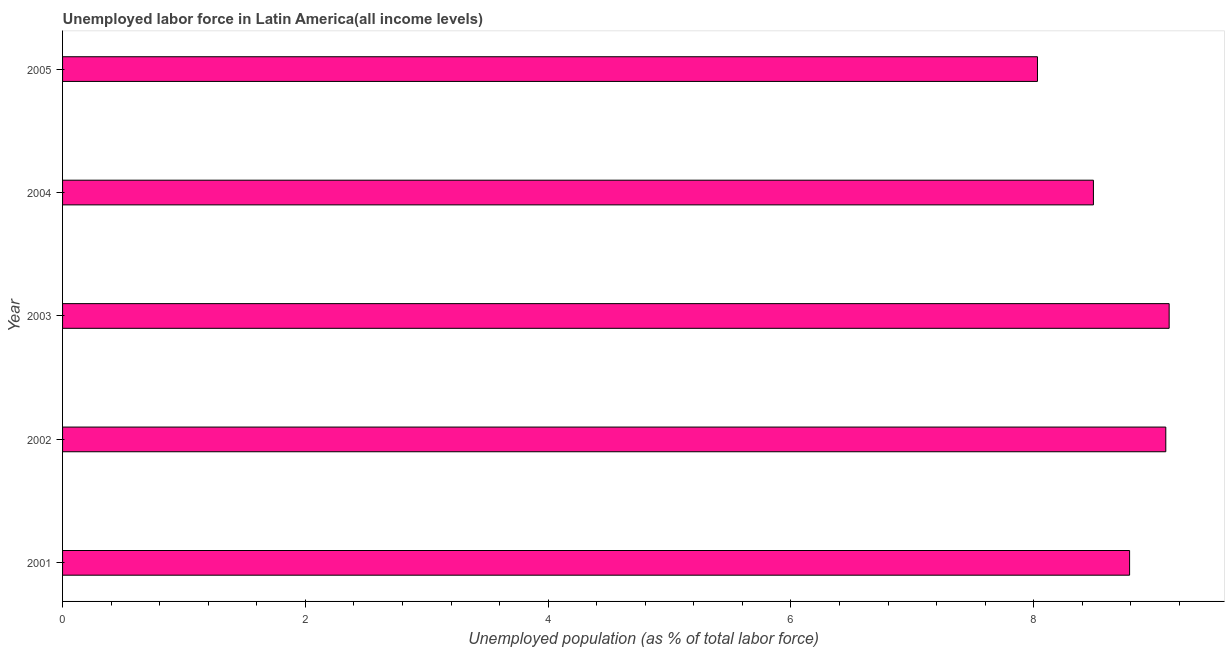Does the graph contain grids?
Your answer should be very brief. No. What is the title of the graph?
Keep it short and to the point. Unemployed labor force in Latin America(all income levels). What is the label or title of the X-axis?
Offer a terse response. Unemployed population (as % of total labor force). What is the total unemployed population in 2002?
Give a very brief answer. 9.09. Across all years, what is the maximum total unemployed population?
Make the answer very short. 9.12. Across all years, what is the minimum total unemployed population?
Your answer should be very brief. 8.03. In which year was the total unemployed population maximum?
Offer a terse response. 2003. What is the sum of the total unemployed population?
Ensure brevity in your answer.  43.52. What is the difference between the total unemployed population in 2002 and 2005?
Provide a succinct answer. 1.06. What is the average total unemployed population per year?
Give a very brief answer. 8.7. What is the median total unemployed population?
Ensure brevity in your answer.  8.79. What is the ratio of the total unemployed population in 2002 to that in 2005?
Offer a terse response. 1.13. Is the total unemployed population in 2001 less than that in 2005?
Your answer should be very brief. No. What is the difference between the highest and the second highest total unemployed population?
Offer a terse response. 0.03. What is the difference between the highest and the lowest total unemployed population?
Your response must be concise. 1.08. How many bars are there?
Your response must be concise. 5. What is the Unemployed population (as % of total labor force) of 2001?
Provide a succinct answer. 8.79. What is the Unemployed population (as % of total labor force) in 2002?
Keep it short and to the point. 9.09. What is the Unemployed population (as % of total labor force) in 2003?
Make the answer very short. 9.12. What is the Unemployed population (as % of total labor force) in 2004?
Keep it short and to the point. 8.49. What is the Unemployed population (as % of total labor force) in 2005?
Keep it short and to the point. 8.03. What is the difference between the Unemployed population (as % of total labor force) in 2001 and 2002?
Ensure brevity in your answer.  -0.3. What is the difference between the Unemployed population (as % of total labor force) in 2001 and 2003?
Give a very brief answer. -0.33. What is the difference between the Unemployed population (as % of total labor force) in 2001 and 2004?
Make the answer very short. 0.3. What is the difference between the Unemployed population (as % of total labor force) in 2001 and 2005?
Your answer should be very brief. 0.76. What is the difference between the Unemployed population (as % of total labor force) in 2002 and 2003?
Keep it short and to the point. -0.03. What is the difference between the Unemployed population (as % of total labor force) in 2002 and 2004?
Give a very brief answer. 0.6. What is the difference between the Unemployed population (as % of total labor force) in 2002 and 2005?
Make the answer very short. 1.06. What is the difference between the Unemployed population (as % of total labor force) in 2003 and 2004?
Offer a terse response. 0.62. What is the difference between the Unemployed population (as % of total labor force) in 2003 and 2005?
Ensure brevity in your answer.  1.08. What is the difference between the Unemployed population (as % of total labor force) in 2004 and 2005?
Provide a short and direct response. 0.46. What is the ratio of the Unemployed population (as % of total labor force) in 2001 to that in 2004?
Make the answer very short. 1.03. What is the ratio of the Unemployed population (as % of total labor force) in 2001 to that in 2005?
Keep it short and to the point. 1.09. What is the ratio of the Unemployed population (as % of total labor force) in 2002 to that in 2003?
Make the answer very short. 1. What is the ratio of the Unemployed population (as % of total labor force) in 2002 to that in 2004?
Your answer should be very brief. 1.07. What is the ratio of the Unemployed population (as % of total labor force) in 2002 to that in 2005?
Make the answer very short. 1.13. What is the ratio of the Unemployed population (as % of total labor force) in 2003 to that in 2004?
Provide a short and direct response. 1.07. What is the ratio of the Unemployed population (as % of total labor force) in 2003 to that in 2005?
Your answer should be very brief. 1.14. What is the ratio of the Unemployed population (as % of total labor force) in 2004 to that in 2005?
Offer a very short reply. 1.06. 